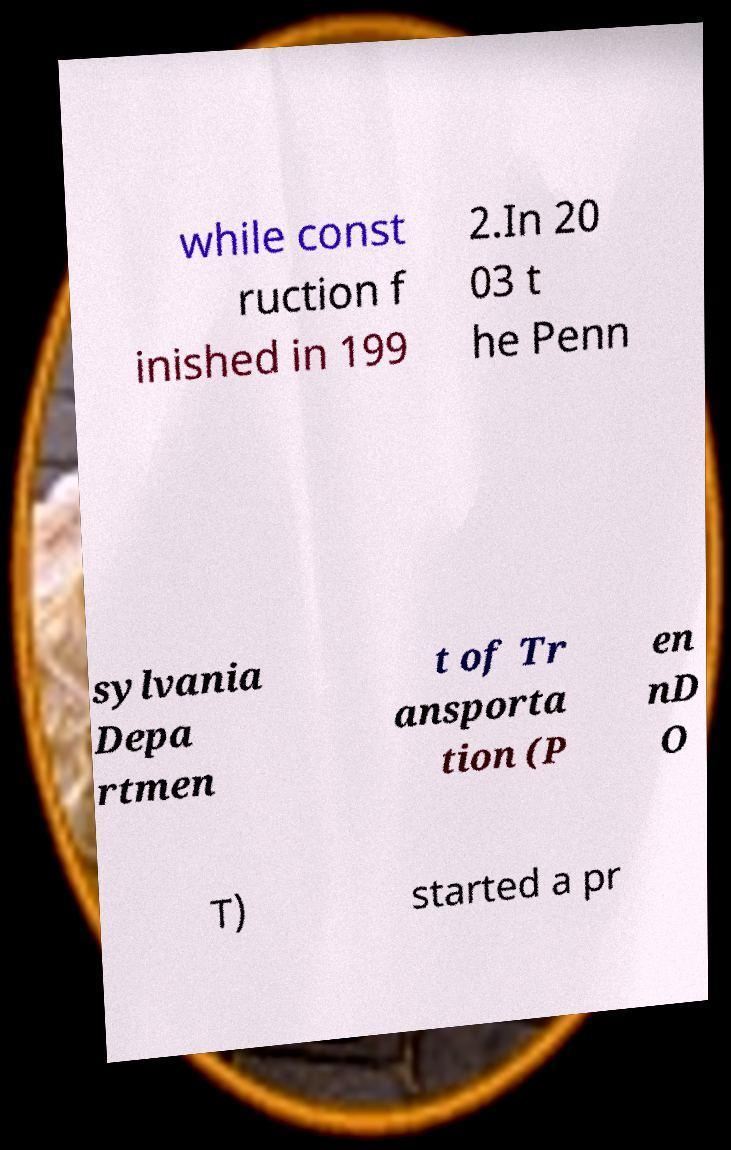Can you read and provide the text displayed in the image?This photo seems to have some interesting text. Can you extract and type it out for me? while const ruction f inished in 199 2.In 20 03 t he Penn sylvania Depa rtmen t of Tr ansporta tion (P en nD O T) started a pr 